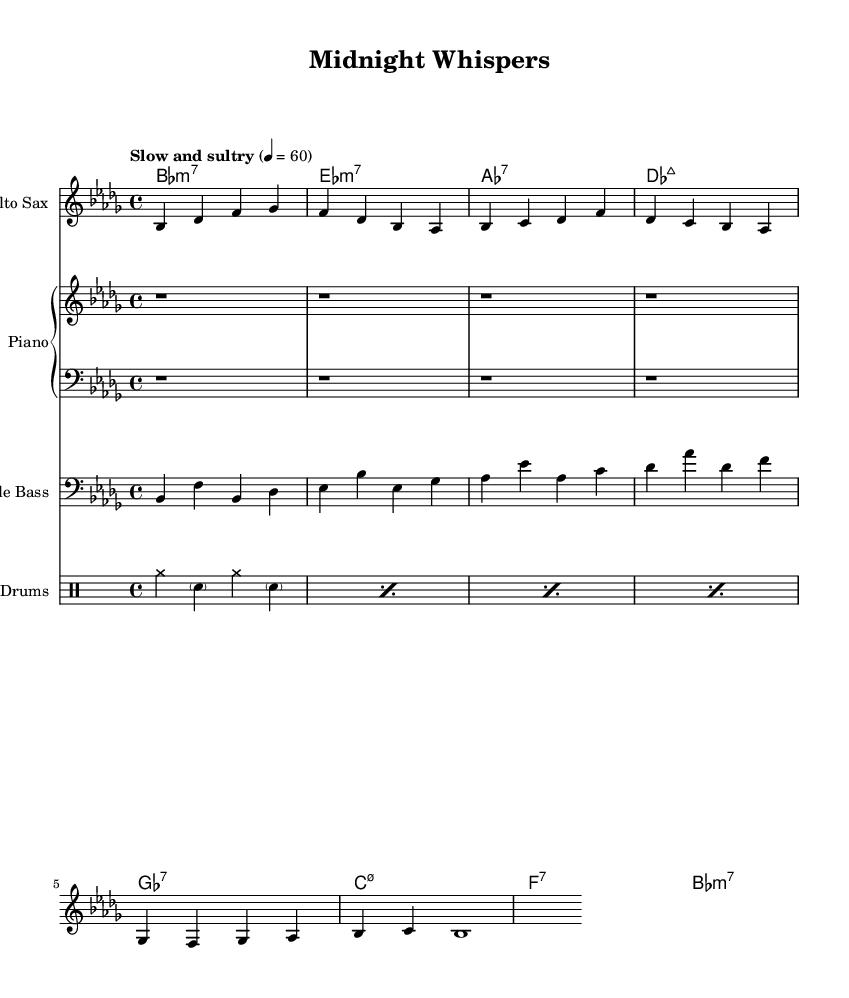What is the key signature of this music? The key signature indicates the notes that are sharp or flat throughout the piece. In this case, the music is in B flat minor, which has five flats (B flat, E flat, A flat, D flat, and G flat).
Answer: B flat minor What is the time signature of this music? The time signature appears at the beginning of the piece, indicating how many beats are in each measure. Here, it shows 4/4, meaning there are four beats per measure.
Answer: 4/4 What is the tempo marking of the piece? The tempo marking is provided in the music, showing how fast or slow the piece should be played. In this case, it states "Slow and sultry," which suggests a relaxed pace.
Answer: Slow and sultry Identify the chord progression used in the piano part. The chord progression can be found by analyzing the sequence of chords specified in the chord mode. The progression is B flat minor 7, E flat minor 7, A flat 7, D flat major 7, G flat 7, C minor 7.5-, F 7, B flat minor 7.
Answer: B flat minor 7, E flat minor 7, A flat 7, D flat major 7, G flat 7, C minor 7.5-, F 7, B flat minor 7 What instruments are included in this score? The score specifies four different parts, which are listed at the top of each staff. The instruments present are Alto Sax, Piano, Double Bass, and Drums.
Answer: Alto Sax, Piano, Double Bass, Drums Which section of the piece has a rest? The score indicates rests with 'r' followed by a number, showing the duration of silence. In the piano staff, there are four measures of rest at the beginning.
Answer: Four measures of rest 